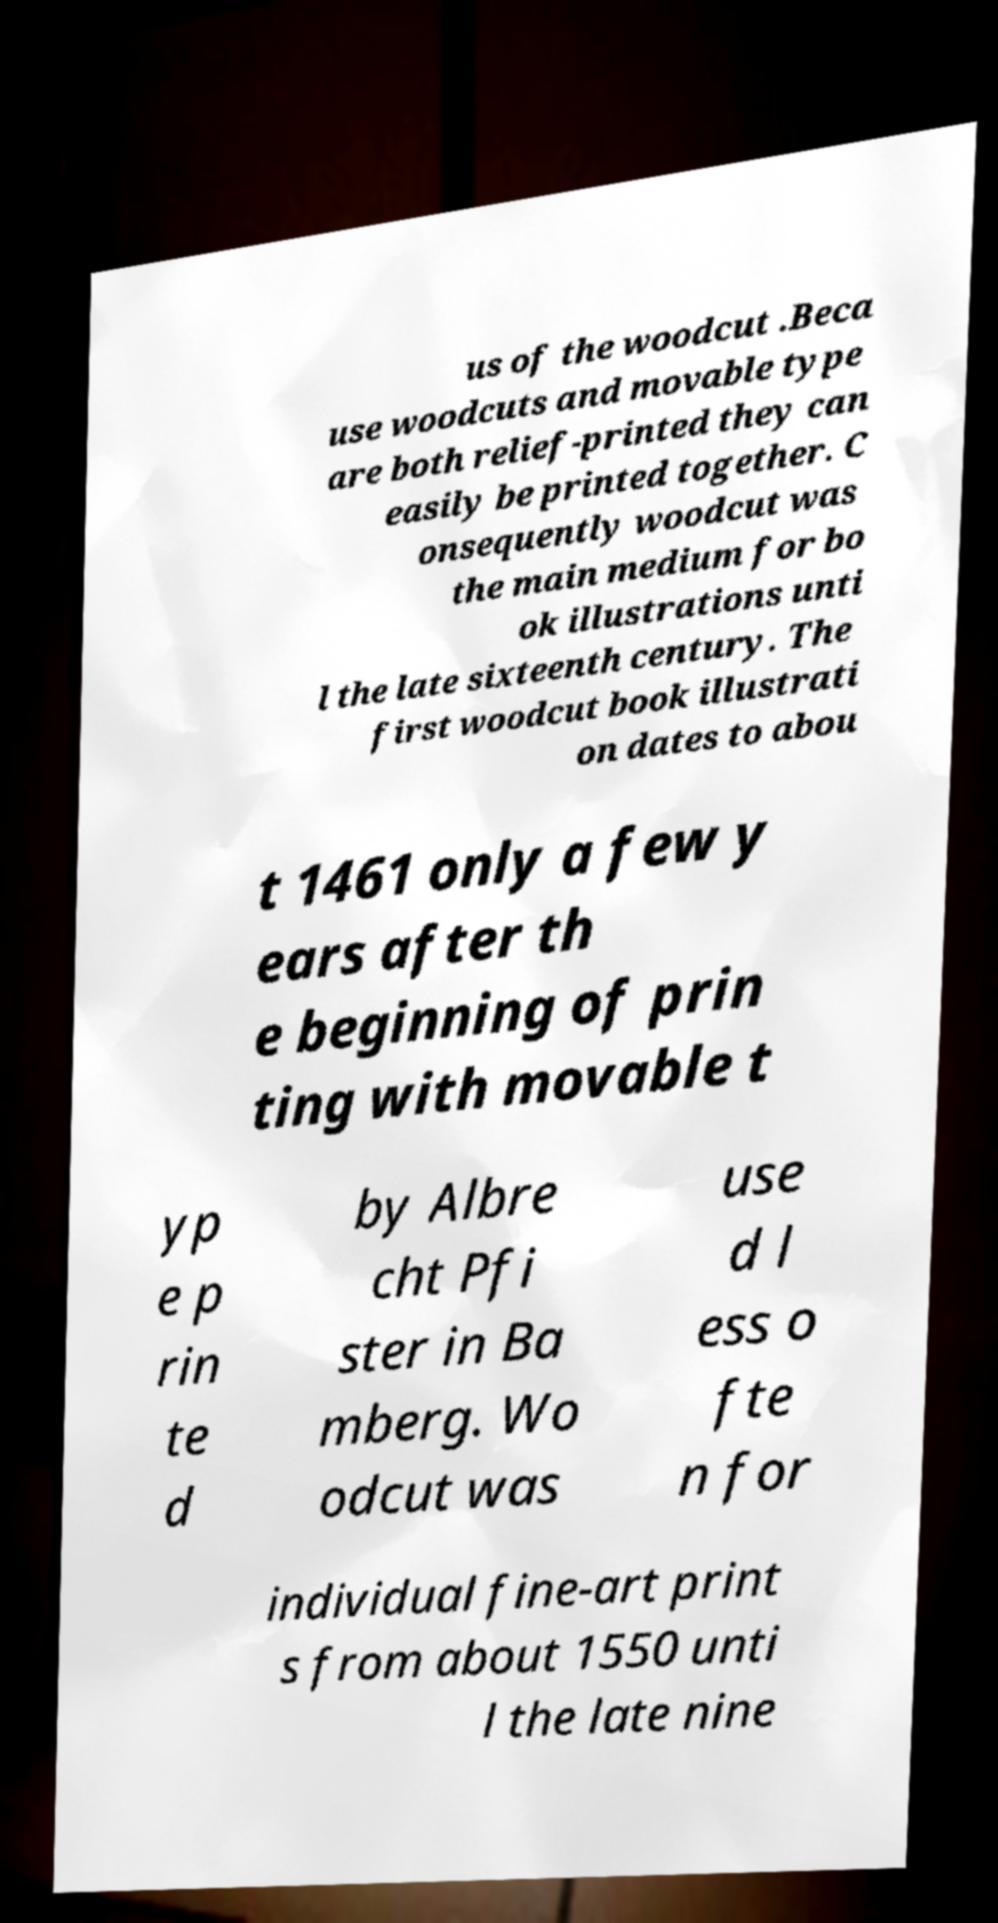Can you read and provide the text displayed in the image?This photo seems to have some interesting text. Can you extract and type it out for me? us of the woodcut .Beca use woodcuts and movable type are both relief-printed they can easily be printed together. C onsequently woodcut was the main medium for bo ok illustrations unti l the late sixteenth century. The first woodcut book illustrati on dates to abou t 1461 only a few y ears after th e beginning of prin ting with movable t yp e p rin te d by Albre cht Pfi ster in Ba mberg. Wo odcut was use d l ess o fte n for individual fine-art print s from about 1550 unti l the late nine 